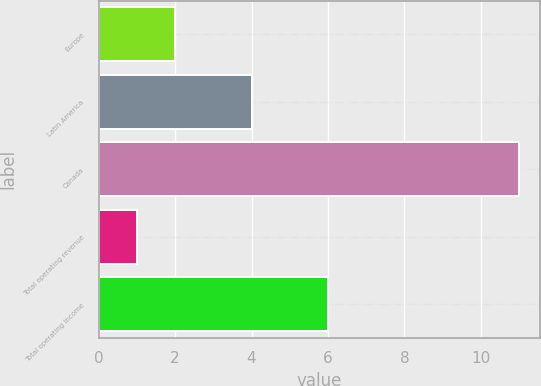Convert chart to OTSL. <chart><loc_0><loc_0><loc_500><loc_500><bar_chart><fcel>Europe<fcel>Latin America<fcel>Canada<fcel>Total operating revenue<fcel>Total operating income<nl><fcel>2<fcel>4<fcel>11<fcel>1<fcel>6<nl></chart> 